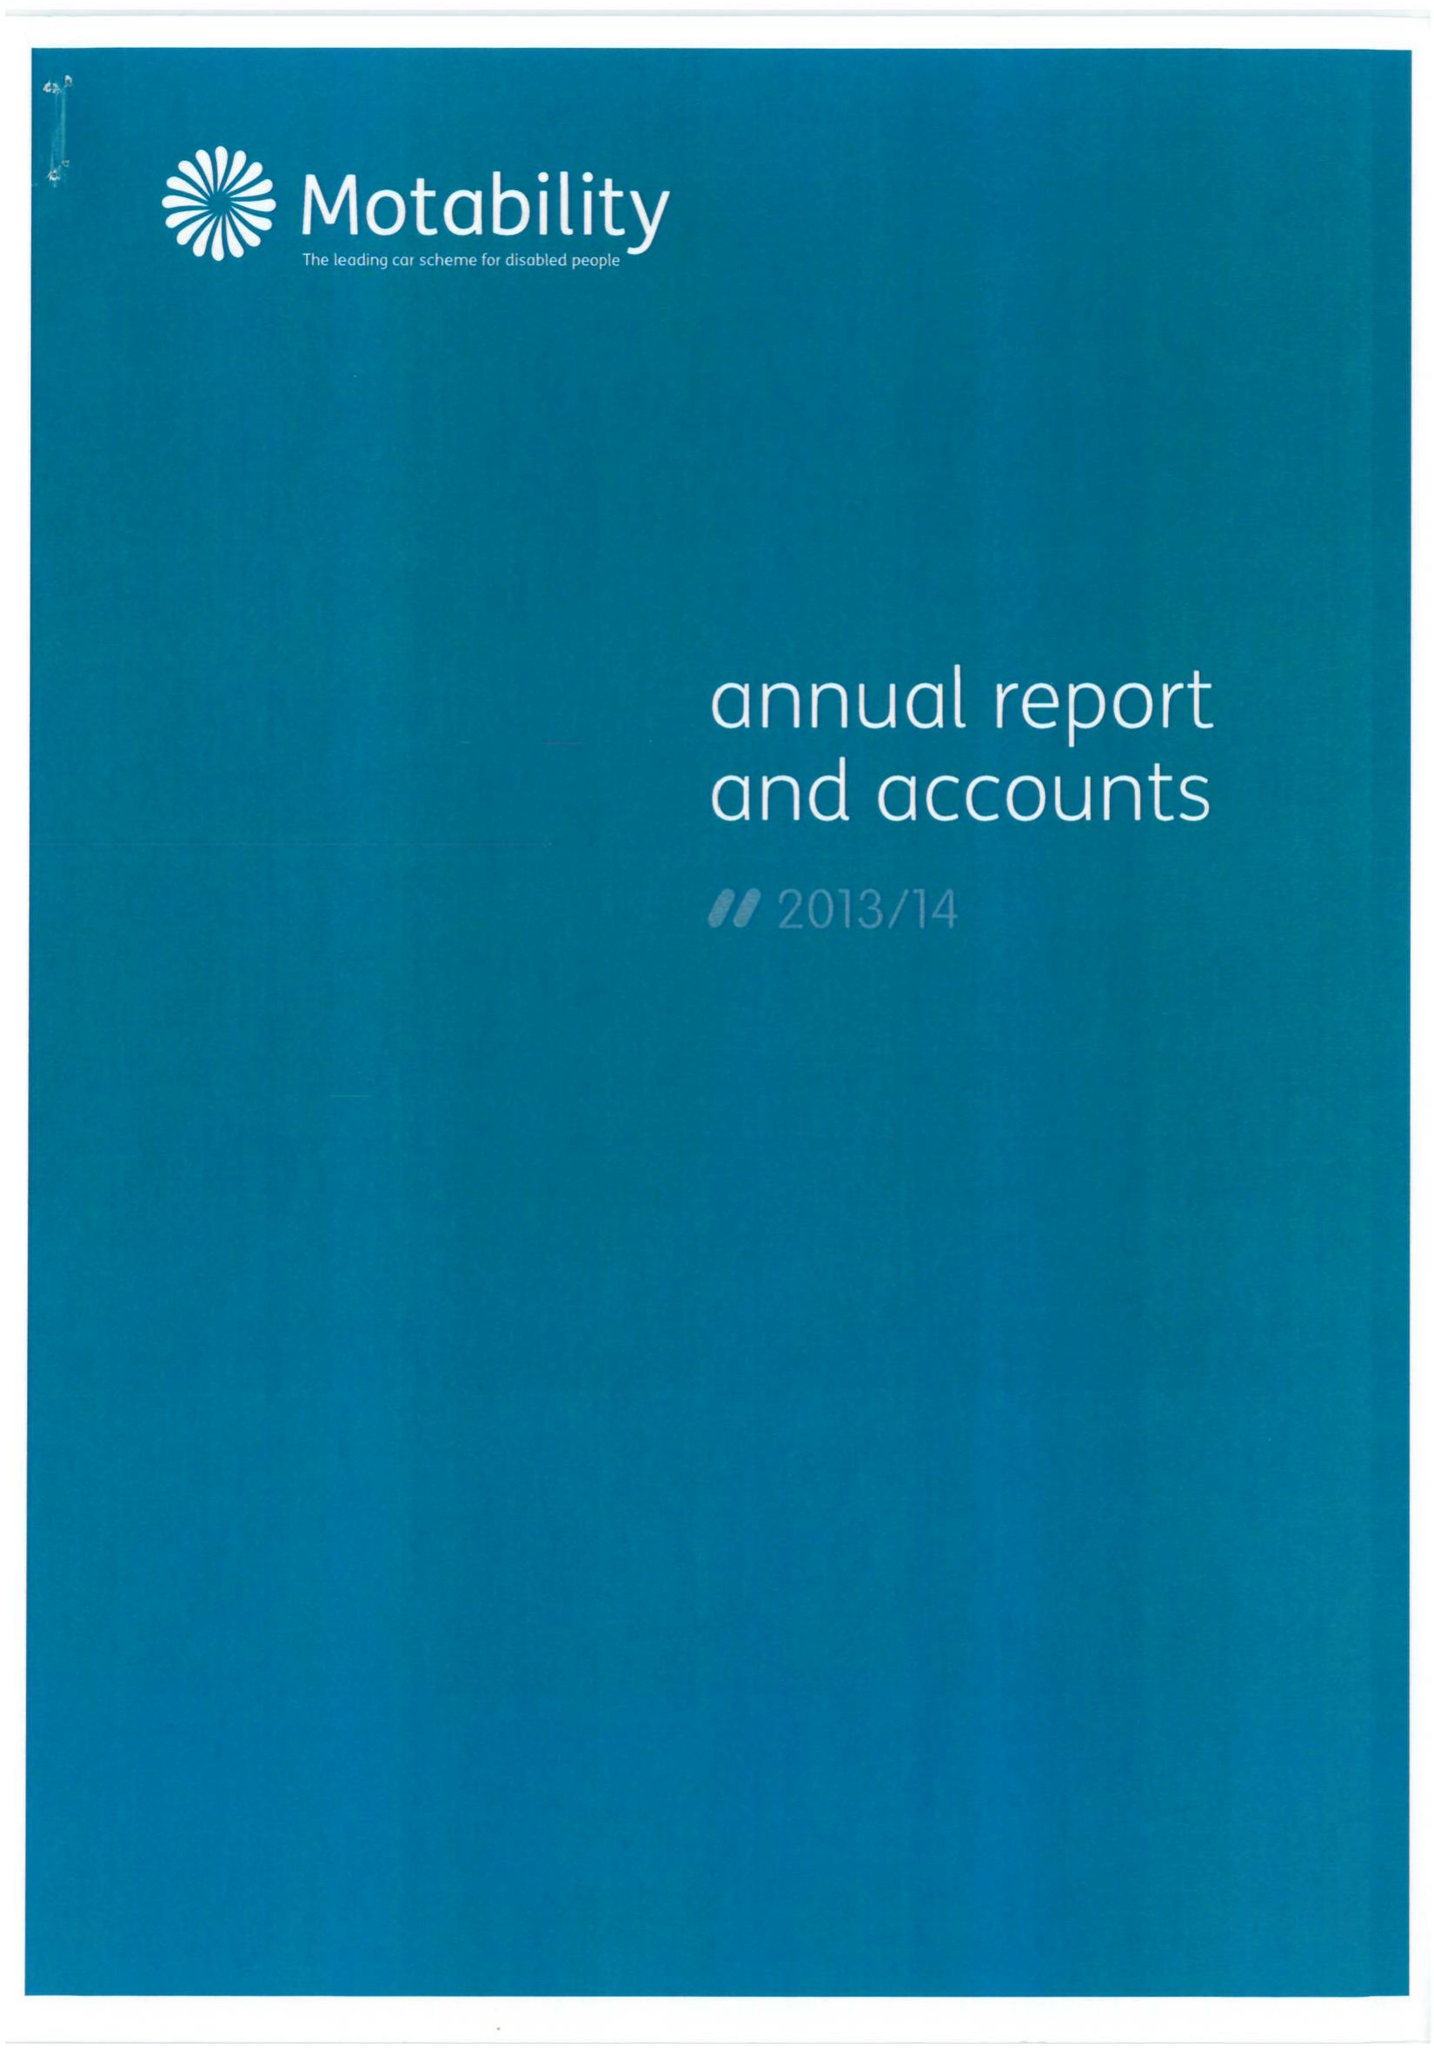What is the value for the report_date?
Answer the question using a single word or phrase. 2014-03-31 